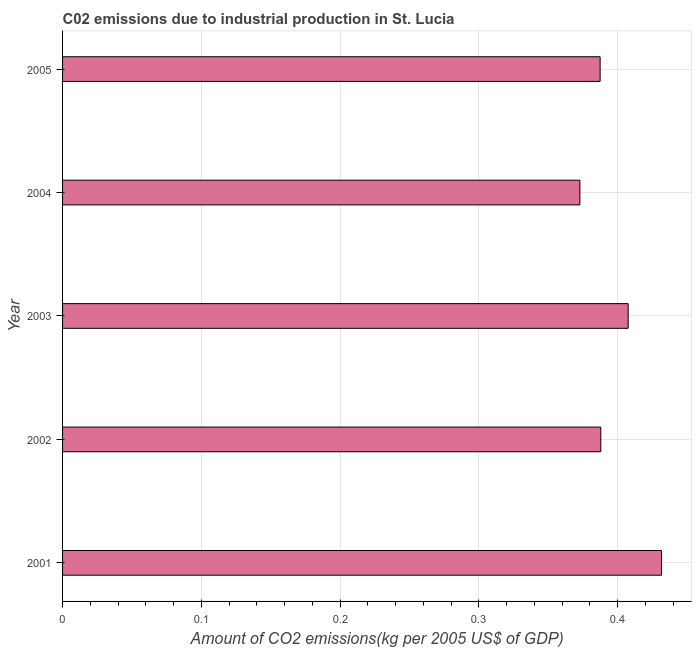Does the graph contain grids?
Make the answer very short. Yes. What is the title of the graph?
Ensure brevity in your answer.  C02 emissions due to industrial production in St. Lucia. What is the label or title of the X-axis?
Offer a terse response. Amount of CO2 emissions(kg per 2005 US$ of GDP). What is the label or title of the Y-axis?
Provide a succinct answer. Year. What is the amount of co2 emissions in 2003?
Ensure brevity in your answer.  0.41. Across all years, what is the maximum amount of co2 emissions?
Offer a terse response. 0.43. Across all years, what is the minimum amount of co2 emissions?
Give a very brief answer. 0.37. In which year was the amount of co2 emissions maximum?
Provide a succinct answer. 2001. In which year was the amount of co2 emissions minimum?
Ensure brevity in your answer.  2004. What is the sum of the amount of co2 emissions?
Keep it short and to the point. 1.99. What is the difference between the amount of co2 emissions in 2001 and 2003?
Give a very brief answer. 0.02. What is the average amount of co2 emissions per year?
Keep it short and to the point. 0.4. What is the median amount of co2 emissions?
Your answer should be very brief. 0.39. In how many years, is the amount of co2 emissions greater than 0.14 kg per 2005 US$ of GDP?
Provide a succinct answer. 5. Do a majority of the years between 2003 and 2004 (inclusive) have amount of co2 emissions greater than 0.22 kg per 2005 US$ of GDP?
Make the answer very short. Yes. What is the ratio of the amount of co2 emissions in 2002 to that in 2005?
Offer a terse response. 1. Is the difference between the amount of co2 emissions in 2001 and 2002 greater than the difference between any two years?
Your answer should be very brief. No. What is the difference between the highest and the second highest amount of co2 emissions?
Ensure brevity in your answer.  0.02. Is the sum of the amount of co2 emissions in 2001 and 2003 greater than the maximum amount of co2 emissions across all years?
Offer a terse response. Yes. How many bars are there?
Keep it short and to the point. 5. Are all the bars in the graph horizontal?
Offer a very short reply. Yes. How many years are there in the graph?
Provide a short and direct response. 5. What is the Amount of CO2 emissions(kg per 2005 US$ of GDP) in 2001?
Ensure brevity in your answer.  0.43. What is the Amount of CO2 emissions(kg per 2005 US$ of GDP) of 2002?
Keep it short and to the point. 0.39. What is the Amount of CO2 emissions(kg per 2005 US$ of GDP) in 2003?
Your answer should be very brief. 0.41. What is the Amount of CO2 emissions(kg per 2005 US$ of GDP) of 2004?
Give a very brief answer. 0.37. What is the Amount of CO2 emissions(kg per 2005 US$ of GDP) in 2005?
Give a very brief answer. 0.39. What is the difference between the Amount of CO2 emissions(kg per 2005 US$ of GDP) in 2001 and 2002?
Provide a succinct answer. 0.04. What is the difference between the Amount of CO2 emissions(kg per 2005 US$ of GDP) in 2001 and 2003?
Keep it short and to the point. 0.02. What is the difference between the Amount of CO2 emissions(kg per 2005 US$ of GDP) in 2001 and 2004?
Provide a succinct answer. 0.06. What is the difference between the Amount of CO2 emissions(kg per 2005 US$ of GDP) in 2001 and 2005?
Offer a terse response. 0.04. What is the difference between the Amount of CO2 emissions(kg per 2005 US$ of GDP) in 2002 and 2003?
Give a very brief answer. -0.02. What is the difference between the Amount of CO2 emissions(kg per 2005 US$ of GDP) in 2002 and 2004?
Offer a very short reply. 0.02. What is the difference between the Amount of CO2 emissions(kg per 2005 US$ of GDP) in 2002 and 2005?
Your answer should be compact. 0. What is the difference between the Amount of CO2 emissions(kg per 2005 US$ of GDP) in 2003 and 2004?
Offer a very short reply. 0.03. What is the difference between the Amount of CO2 emissions(kg per 2005 US$ of GDP) in 2003 and 2005?
Your answer should be very brief. 0.02. What is the difference between the Amount of CO2 emissions(kg per 2005 US$ of GDP) in 2004 and 2005?
Your answer should be compact. -0.01. What is the ratio of the Amount of CO2 emissions(kg per 2005 US$ of GDP) in 2001 to that in 2002?
Give a very brief answer. 1.11. What is the ratio of the Amount of CO2 emissions(kg per 2005 US$ of GDP) in 2001 to that in 2003?
Provide a short and direct response. 1.06. What is the ratio of the Amount of CO2 emissions(kg per 2005 US$ of GDP) in 2001 to that in 2004?
Provide a succinct answer. 1.16. What is the ratio of the Amount of CO2 emissions(kg per 2005 US$ of GDP) in 2001 to that in 2005?
Offer a very short reply. 1.11. What is the ratio of the Amount of CO2 emissions(kg per 2005 US$ of GDP) in 2002 to that in 2003?
Offer a terse response. 0.95. What is the ratio of the Amount of CO2 emissions(kg per 2005 US$ of GDP) in 2002 to that in 2004?
Your response must be concise. 1.04. What is the ratio of the Amount of CO2 emissions(kg per 2005 US$ of GDP) in 2002 to that in 2005?
Your answer should be compact. 1. What is the ratio of the Amount of CO2 emissions(kg per 2005 US$ of GDP) in 2003 to that in 2004?
Make the answer very short. 1.09. What is the ratio of the Amount of CO2 emissions(kg per 2005 US$ of GDP) in 2003 to that in 2005?
Your answer should be compact. 1.05. What is the ratio of the Amount of CO2 emissions(kg per 2005 US$ of GDP) in 2004 to that in 2005?
Your answer should be very brief. 0.96. 